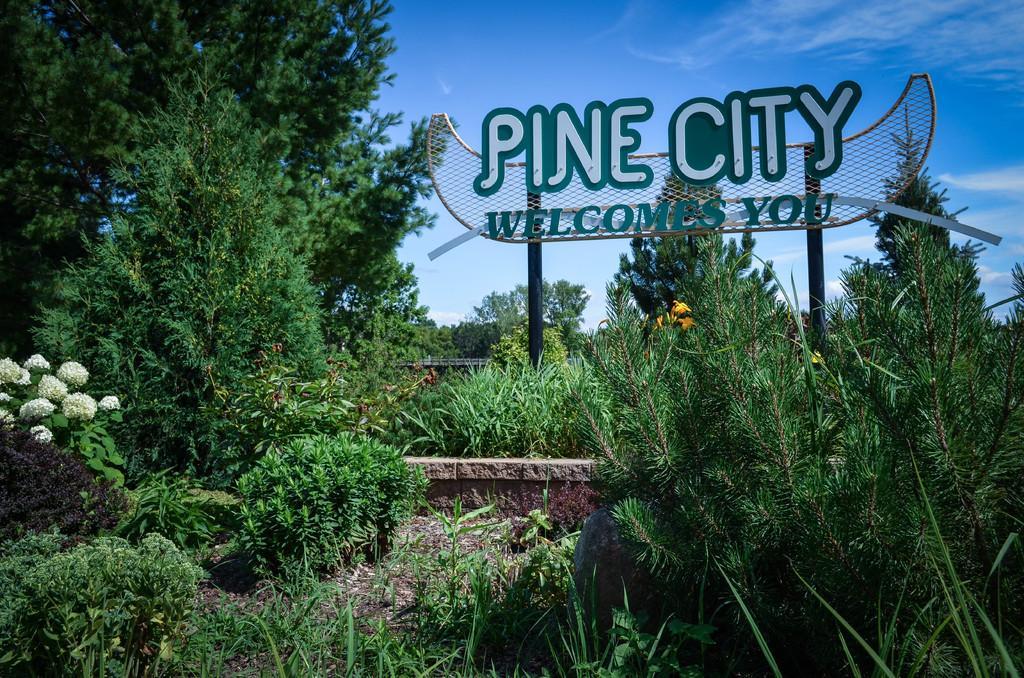Could you give a brief overview of what you see in this image? In this image there are trees and plants. In the center there is a board. In the background there is sky. 